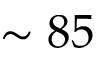Convert formula to latex. <formula><loc_0><loc_0><loc_500><loc_500>\sim 8 5</formula> 